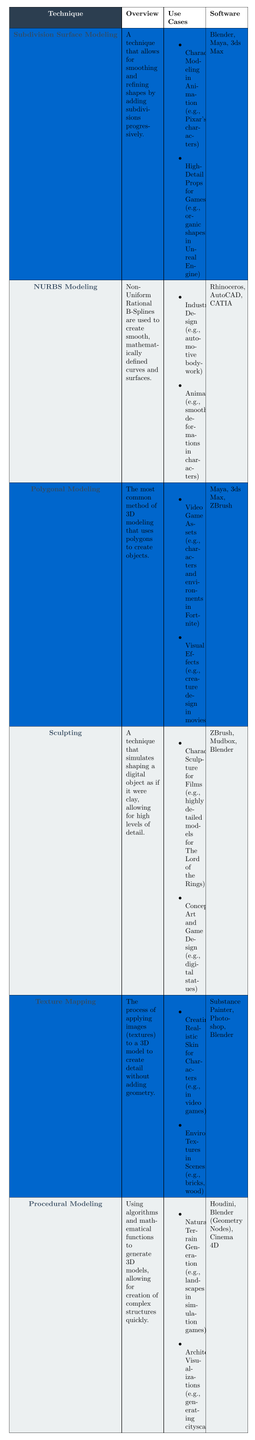What is the overview of Subdivision Surface Modeling? The overview of Subdivision Surface Modeling is presented in the table under the "Overview" column, which states that it is a technique that allows for smoothing and refining shapes by adding subdivisions progressively.
Answer: A technique that allows for smoothing and refining shapes by adding subdivisions progressively Which software is used for NURBS Modeling? The table lists the software associated with NURBS Modeling in the "Software" column, which includes Rhinoceros, AutoCAD, and CATIA.
Answer: Rhinoceros, AutoCAD, CATIA List one use case for Polygonal Modeling. The table contains a "Use Cases" section for Polygonal Modeling, which includes various examples. One example provided is "Video Game Assets (e.g., characters and environments in Fortnite)."
Answer: Video Game Assets (e.g., characters and environments in Fortnite) Which technique uses algorithms to generate 3D models? Referring to the "Technique" column in the table, Procedural Modeling is identified as the method that uses algorithms and mathematical functions to generate 3D models.
Answer: Procedural Modeling How many software applications are associated with Sculpting? The "Software" column for Sculpting mentions three software applications: ZBrush, Mudbox, and Blender. Therefore, the total count is three.
Answer: Three Is Texture Mapping primarily used for creating detailed geometry? The overview for Texture Mapping in the table mentions that it is the process of applying images to a 3D model to create detail without adding geometry, indicating that its main purpose is not for creating detailed geometry.
Answer: No Which 3D modeling techniques are used in animation? By examining the "Use Cases" sections for each technique in the table, it is determined that Subdivision Surface Modeling, NURBS Modeling, Sculpting, and Texture Mapping have listed animation-related use cases.
Answer: Four techniques: Subdivision Surface Modeling, NURBS Modeling, Sculpting, Texture Mapping What is the primary focus of Procedural Modeling in comparison to other techniques? From the table, Procedural Modeling stands out as it focuses on using algorithms and mathematical functions to create complex structures quickly, unlike most techniques that emphasize manual modeling or direct shaping.
Answer: Creating complex structures quickly using algorithms Which technique is commonly used for creating realistic skin in video games? The "Use Cases" for Texture Mapping specifically states that it is used for creating realistic skin for characters in video games.
Answer: Texture Mapping Are there more use cases in Polygonal Modeling compared to Sculpting? By counting the entries from the "Use Cases" column, Polygonal Modeling has two use cases, while Sculpting also lists two use cases. Therefore, they are equal in number.
Answer: No, they have the same number 